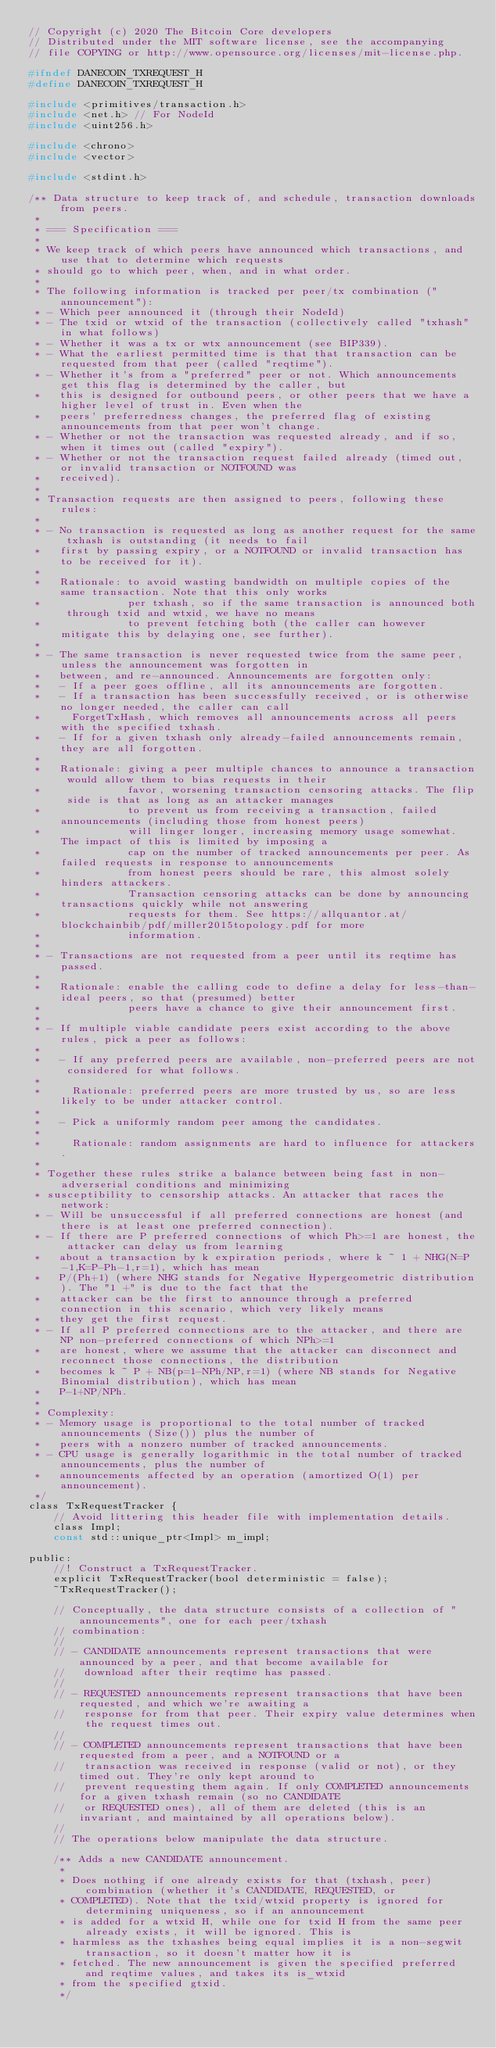Convert code to text. <code><loc_0><loc_0><loc_500><loc_500><_C_>// Copyright (c) 2020 The Bitcoin Core developers
// Distributed under the MIT software license, see the accompanying
// file COPYING or http://www.opensource.org/licenses/mit-license.php.

#ifndef DANECOIN_TXREQUEST_H
#define DANECOIN_TXREQUEST_H

#include <primitives/transaction.h>
#include <net.h> // For NodeId
#include <uint256.h>

#include <chrono>
#include <vector>

#include <stdint.h>

/** Data structure to keep track of, and schedule, transaction downloads from peers.
 *
 * === Specification ===
 *
 * We keep track of which peers have announced which transactions, and use that to determine which requests
 * should go to which peer, when, and in what order.
 *
 * The following information is tracked per peer/tx combination ("announcement"):
 * - Which peer announced it (through their NodeId)
 * - The txid or wtxid of the transaction (collectively called "txhash" in what follows)
 * - Whether it was a tx or wtx announcement (see BIP339).
 * - What the earliest permitted time is that that transaction can be requested from that peer (called "reqtime").
 * - Whether it's from a "preferred" peer or not. Which announcements get this flag is determined by the caller, but
 *   this is designed for outbound peers, or other peers that we have a higher level of trust in. Even when the
 *   peers' preferredness changes, the preferred flag of existing announcements from that peer won't change.
 * - Whether or not the transaction was requested already, and if so, when it times out (called "expiry").
 * - Whether or not the transaction request failed already (timed out, or invalid transaction or NOTFOUND was
 *   received).
 *
 * Transaction requests are then assigned to peers, following these rules:
 *
 * - No transaction is requested as long as another request for the same txhash is outstanding (it needs to fail
 *   first by passing expiry, or a NOTFOUND or invalid transaction has to be received for it).
 *
 *   Rationale: to avoid wasting bandwidth on multiple copies of the same transaction. Note that this only works
 *              per txhash, so if the same transaction is announced both through txid and wtxid, we have no means
 *              to prevent fetching both (the caller can however mitigate this by delaying one, see further).
 *
 * - The same transaction is never requested twice from the same peer, unless the announcement was forgotten in
 *   between, and re-announced. Announcements are forgotten only:
 *   - If a peer goes offline, all its announcements are forgotten.
 *   - If a transaction has been successfully received, or is otherwise no longer needed, the caller can call
 *     ForgetTxHash, which removes all announcements across all peers with the specified txhash.
 *   - If for a given txhash only already-failed announcements remain, they are all forgotten.
 *
 *   Rationale: giving a peer multiple chances to announce a transaction would allow them to bias requests in their
 *              favor, worsening transaction censoring attacks. The flip side is that as long as an attacker manages
 *              to prevent us from receiving a transaction, failed announcements (including those from honest peers)
 *              will linger longer, increasing memory usage somewhat. The impact of this is limited by imposing a
 *              cap on the number of tracked announcements per peer. As failed requests in response to announcements
 *              from honest peers should be rare, this almost solely hinders attackers.
 *              Transaction censoring attacks can be done by announcing transactions quickly while not answering
 *              requests for them. See https://allquantor.at/blockchainbib/pdf/miller2015topology.pdf for more
 *              information.
 *
 * - Transactions are not requested from a peer until its reqtime has passed.
 *
 *   Rationale: enable the calling code to define a delay for less-than-ideal peers, so that (presumed) better
 *              peers have a chance to give their announcement first.
 *
 * - If multiple viable candidate peers exist according to the above rules, pick a peer as follows:
 *
 *   - If any preferred peers are available, non-preferred peers are not considered for what follows.
 *
 *     Rationale: preferred peers are more trusted by us, so are less likely to be under attacker control.
 *
 *   - Pick a uniformly random peer among the candidates.
 *
 *     Rationale: random assignments are hard to influence for attackers.
 *
 * Together these rules strike a balance between being fast in non-adverserial conditions and minimizing
 * susceptibility to censorship attacks. An attacker that races the network:
 * - Will be unsuccessful if all preferred connections are honest (and there is at least one preferred connection).
 * - If there are P preferred connections of which Ph>=1 are honest, the attacker can delay us from learning
 *   about a transaction by k expiration periods, where k ~ 1 + NHG(N=P-1,K=P-Ph-1,r=1), which has mean
 *   P/(Ph+1) (where NHG stands for Negative Hypergeometric distribution). The "1 +" is due to the fact that the
 *   attacker can be the first to announce through a preferred connection in this scenario, which very likely means
 *   they get the first request.
 * - If all P preferred connections are to the attacker, and there are NP non-preferred connections of which NPh>=1
 *   are honest, where we assume that the attacker can disconnect and reconnect those connections, the distribution
 *   becomes k ~ P + NB(p=1-NPh/NP,r=1) (where NB stands for Negative Binomial distribution), which has mean
 *   P-1+NP/NPh.
 *
 * Complexity:
 * - Memory usage is proportional to the total number of tracked announcements (Size()) plus the number of
 *   peers with a nonzero number of tracked announcements.
 * - CPU usage is generally logarithmic in the total number of tracked announcements, plus the number of
 *   announcements affected by an operation (amortized O(1) per announcement).
 */
class TxRequestTracker {
    // Avoid littering this header file with implementation details.
    class Impl;
    const std::unique_ptr<Impl> m_impl;

public:
    //! Construct a TxRequestTracker.
    explicit TxRequestTracker(bool deterministic = false);
    ~TxRequestTracker();

    // Conceptually, the data structure consists of a collection of "announcements", one for each peer/txhash
    // combination:
    //
    // - CANDIDATE announcements represent transactions that were announced by a peer, and that become available for
    //   download after their reqtime has passed.
    //
    // - REQUESTED announcements represent transactions that have been requested, and which we're awaiting a
    //   response for from that peer. Their expiry value determines when the request times out.
    //
    // - COMPLETED announcements represent transactions that have been requested from a peer, and a NOTFOUND or a
    //   transaction was received in response (valid or not), or they timed out. They're only kept around to
    //   prevent requesting them again. If only COMPLETED announcements for a given txhash remain (so no CANDIDATE
    //   or REQUESTED ones), all of them are deleted (this is an invariant, and maintained by all operations below).
    //
    // The operations below manipulate the data structure.

    /** Adds a new CANDIDATE announcement.
     *
     * Does nothing if one already exists for that (txhash, peer) combination (whether it's CANDIDATE, REQUESTED, or
     * COMPLETED). Note that the txid/wtxid property is ignored for determining uniqueness, so if an announcement
     * is added for a wtxid H, while one for txid H from the same peer already exists, it will be ignored. This is
     * harmless as the txhashes being equal implies it is a non-segwit transaction, so it doesn't matter how it is
     * fetched. The new announcement is given the specified preferred and reqtime values, and takes its is_wtxid
     * from the specified gtxid.
     */</code> 